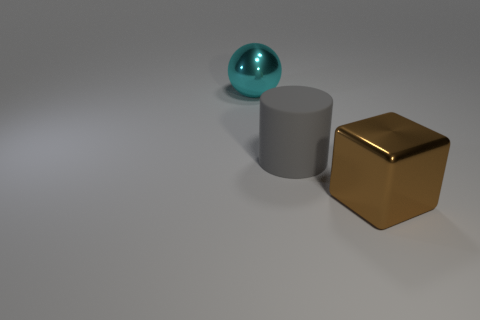There is a metallic object left of the big thing that is in front of the rubber object; what color is it?
Keep it short and to the point. Cyan. Are there fewer cyan metallic things than big shiny things?
Provide a short and direct response. Yes. Is there a thing that has the same material as the brown cube?
Your response must be concise. Yes. Are there any large cyan spheres behind the cylinder?
Your answer should be very brief. Yes. What number of big gray objects are the same shape as the brown metal object?
Make the answer very short. 0. Is the cylinder made of the same material as the large thing that is in front of the cylinder?
Offer a terse response. No. How many small purple objects are there?
Your response must be concise. 0. How many gray spheres are the same size as the matte thing?
Your answer should be very brief. 0. What material is the gray cylinder that is the same size as the cyan shiny sphere?
Offer a very short reply. Rubber. The large metal object on the right side of the cyan metallic sphere has what shape?
Give a very brief answer. Cube. 